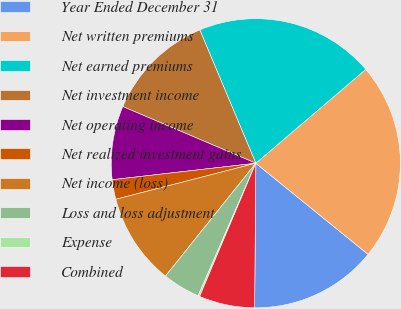Convert chart to OTSL. <chart><loc_0><loc_0><loc_500><loc_500><pie_chart><fcel>Year Ended December 31<fcel>Net written premiums<fcel>Net earned premiums<fcel>Net investment income<fcel>Net operating income<fcel>Net realized investment gains<fcel>Net income (loss)<fcel>Loss and loss adjustment<fcel>Expense<fcel>Combined<nl><fcel>14.28%<fcel>22.1%<fcel>20.09%<fcel>12.26%<fcel>8.23%<fcel>2.19%<fcel>10.25%<fcel>4.21%<fcel>0.18%<fcel>6.22%<nl></chart> 